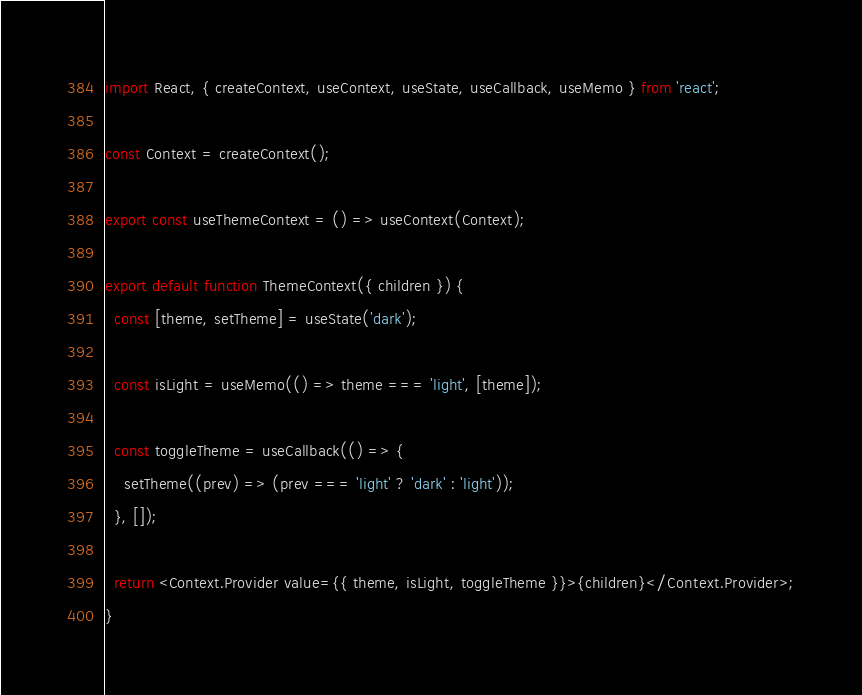<code> <loc_0><loc_0><loc_500><loc_500><_JavaScript_>import React, { createContext, useContext, useState, useCallback, useMemo } from 'react';

const Context = createContext();

export const useThemeContext = () => useContext(Context);

export default function ThemeContext({ children }) {
  const [theme, setTheme] = useState('dark');

  const isLight = useMemo(() => theme === 'light', [theme]);

  const toggleTheme = useCallback(() => {
    setTheme((prev) => (prev === 'light' ? 'dark' : 'light'));
  }, []);

  return <Context.Provider value={{ theme, isLight, toggleTheme }}>{children}</Context.Provider>;
}
</code> 